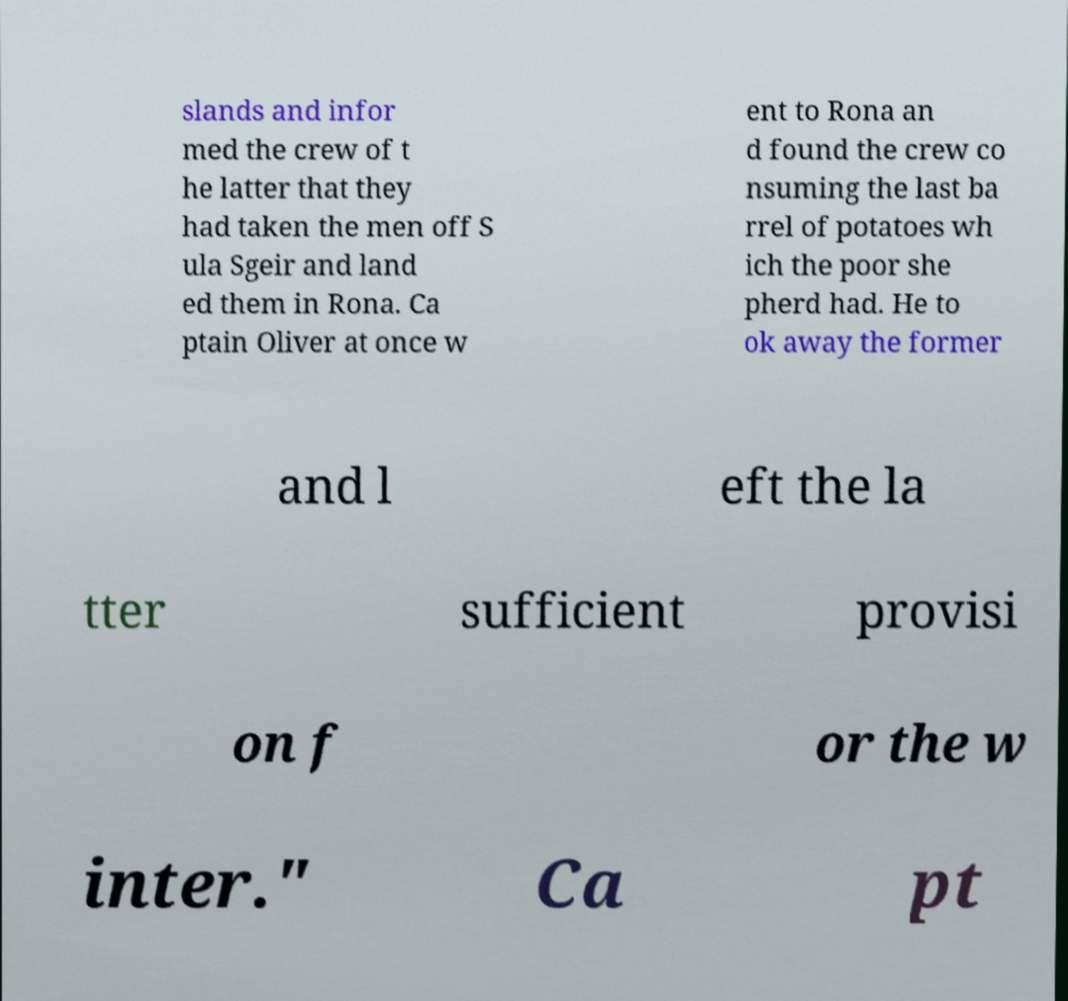I need the written content from this picture converted into text. Can you do that? slands and infor med the crew of t he latter that they had taken the men off S ula Sgeir and land ed them in Rona. Ca ptain Oliver at once w ent to Rona an d found the crew co nsuming the last ba rrel of potatoes wh ich the poor she pherd had. He to ok away the former and l eft the la tter sufficient provisi on f or the w inter." Ca pt 